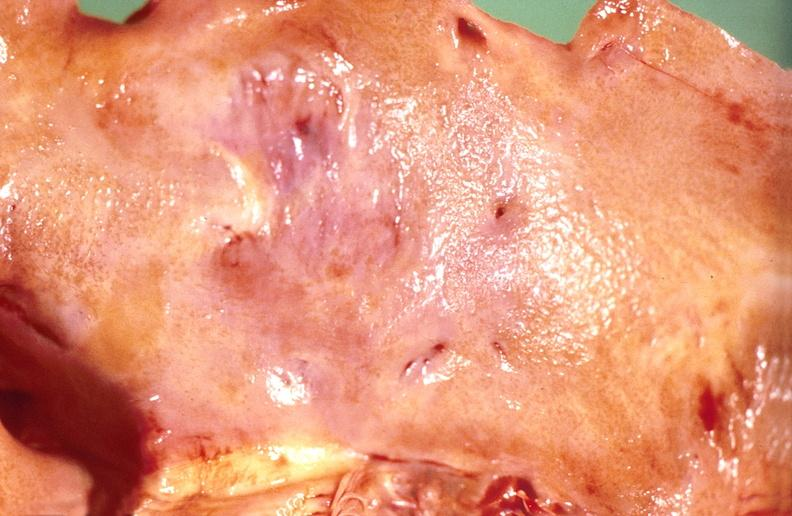what is present?
Answer the question using a single word or phrase. Cardiovascular 